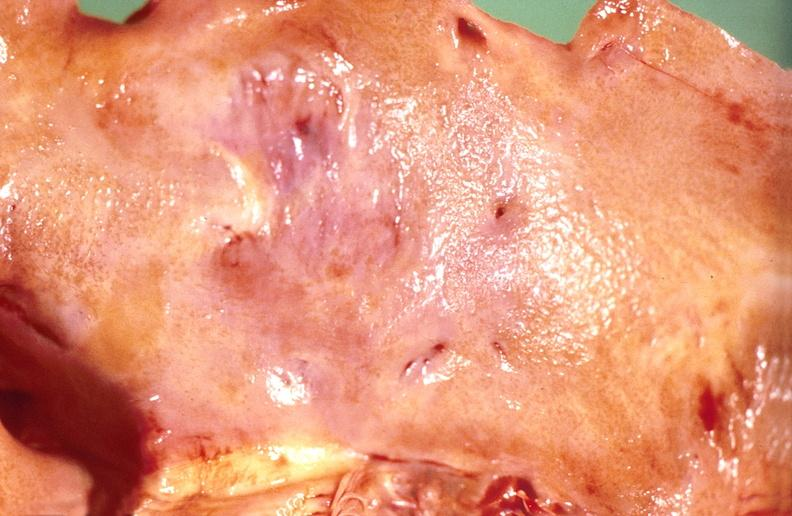what is present?
Answer the question using a single word or phrase. Cardiovascular 